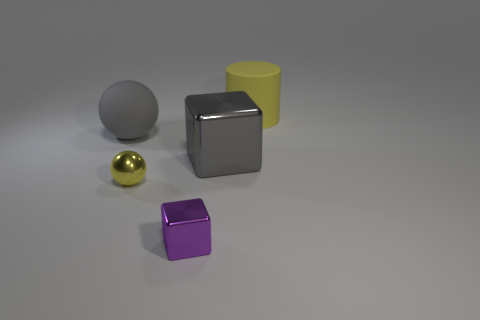What color is the small shiny object that is behind the small purple object? yellow 